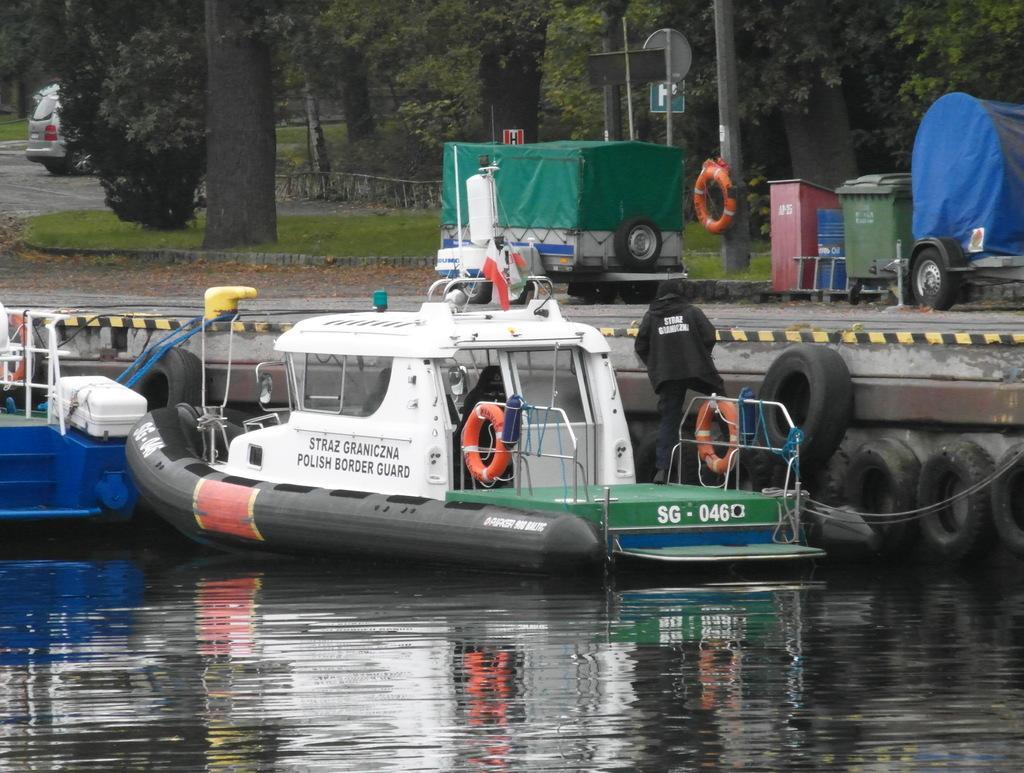In one or two sentences, can you explain what this image depicts? In the middle of the picture, we see a boat and tubes. At the bottom, we see water and this water might be in the lake or pond. Beside the boat, we see the pavement. We see the vehicle is parked on the road. Beside that, we see the poles, boards and a tube in orange color. On the right side, we see a trolley and the garbage bins in red, blue and green color. There are trees and a wooden fence in the background. On the left side, we see a car. 